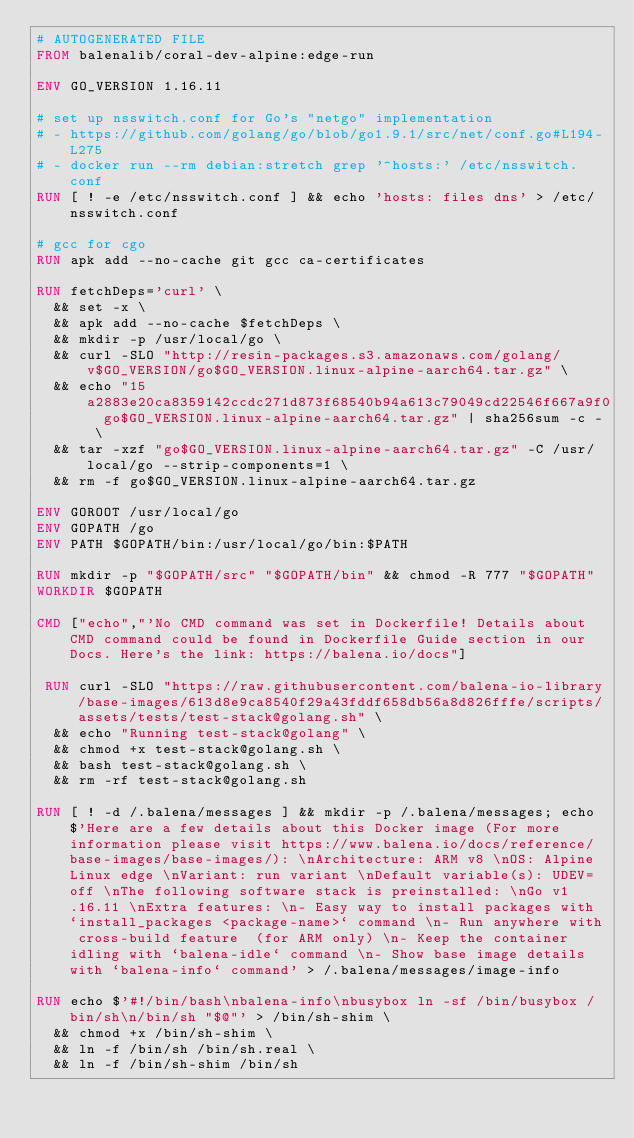<code> <loc_0><loc_0><loc_500><loc_500><_Dockerfile_># AUTOGENERATED FILE
FROM balenalib/coral-dev-alpine:edge-run

ENV GO_VERSION 1.16.11

# set up nsswitch.conf for Go's "netgo" implementation
# - https://github.com/golang/go/blob/go1.9.1/src/net/conf.go#L194-L275
# - docker run --rm debian:stretch grep '^hosts:' /etc/nsswitch.conf
RUN [ ! -e /etc/nsswitch.conf ] && echo 'hosts: files dns' > /etc/nsswitch.conf

# gcc for cgo
RUN apk add --no-cache git gcc ca-certificates

RUN fetchDeps='curl' \
	&& set -x \
	&& apk add --no-cache $fetchDeps \
	&& mkdir -p /usr/local/go \
	&& curl -SLO "http://resin-packages.s3.amazonaws.com/golang/v$GO_VERSION/go$GO_VERSION.linux-alpine-aarch64.tar.gz" \
	&& echo "15a2883e20ca8359142ccdc271d873f68540b94a613c79049cd22546f667a9f0  go$GO_VERSION.linux-alpine-aarch64.tar.gz" | sha256sum -c - \
	&& tar -xzf "go$GO_VERSION.linux-alpine-aarch64.tar.gz" -C /usr/local/go --strip-components=1 \
	&& rm -f go$GO_VERSION.linux-alpine-aarch64.tar.gz

ENV GOROOT /usr/local/go
ENV GOPATH /go
ENV PATH $GOPATH/bin:/usr/local/go/bin:$PATH

RUN mkdir -p "$GOPATH/src" "$GOPATH/bin" && chmod -R 777 "$GOPATH"
WORKDIR $GOPATH

CMD ["echo","'No CMD command was set in Dockerfile! Details about CMD command could be found in Dockerfile Guide section in our Docs. Here's the link: https://balena.io/docs"]

 RUN curl -SLO "https://raw.githubusercontent.com/balena-io-library/base-images/613d8e9ca8540f29a43fddf658db56a8d826fffe/scripts/assets/tests/test-stack@golang.sh" \
  && echo "Running test-stack@golang" \
  && chmod +x test-stack@golang.sh \
  && bash test-stack@golang.sh \
  && rm -rf test-stack@golang.sh 

RUN [ ! -d /.balena/messages ] && mkdir -p /.balena/messages; echo $'Here are a few details about this Docker image (For more information please visit https://www.balena.io/docs/reference/base-images/base-images/): \nArchitecture: ARM v8 \nOS: Alpine Linux edge \nVariant: run variant \nDefault variable(s): UDEV=off \nThe following software stack is preinstalled: \nGo v1.16.11 \nExtra features: \n- Easy way to install packages with `install_packages <package-name>` command \n- Run anywhere with cross-build feature  (for ARM only) \n- Keep the container idling with `balena-idle` command \n- Show base image details with `balena-info` command' > /.balena/messages/image-info

RUN echo $'#!/bin/bash\nbalena-info\nbusybox ln -sf /bin/busybox /bin/sh\n/bin/sh "$@"' > /bin/sh-shim \
	&& chmod +x /bin/sh-shim \
	&& ln -f /bin/sh /bin/sh.real \
	&& ln -f /bin/sh-shim /bin/sh</code> 